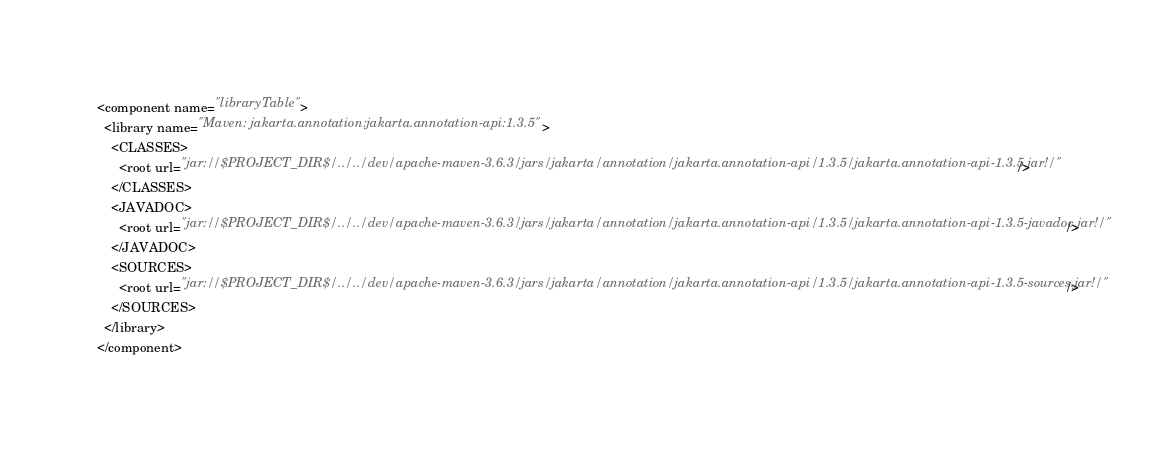Convert code to text. <code><loc_0><loc_0><loc_500><loc_500><_XML_><component name="libraryTable">
  <library name="Maven: jakarta.annotation:jakarta.annotation-api:1.3.5">
    <CLASSES>
      <root url="jar://$PROJECT_DIR$/../../dev/apache-maven-3.6.3/jars/jakarta/annotation/jakarta.annotation-api/1.3.5/jakarta.annotation-api-1.3.5.jar!/" />
    </CLASSES>
    <JAVADOC>
      <root url="jar://$PROJECT_DIR$/../../dev/apache-maven-3.6.3/jars/jakarta/annotation/jakarta.annotation-api/1.3.5/jakarta.annotation-api-1.3.5-javadoc.jar!/" />
    </JAVADOC>
    <SOURCES>
      <root url="jar://$PROJECT_DIR$/../../dev/apache-maven-3.6.3/jars/jakarta/annotation/jakarta.annotation-api/1.3.5/jakarta.annotation-api-1.3.5-sources.jar!/" />
    </SOURCES>
  </library>
</component></code> 